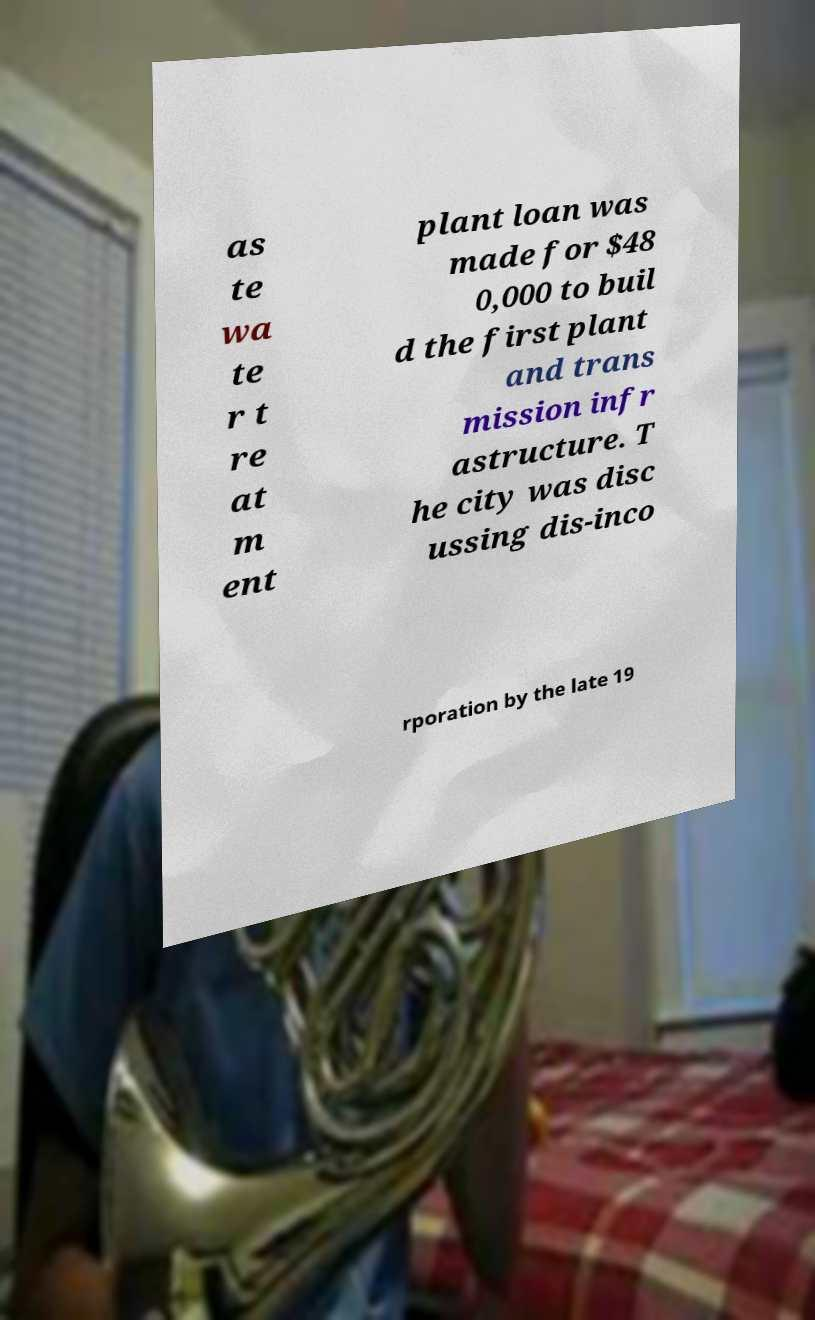What messages or text are displayed in this image? I need them in a readable, typed format. as te wa te r t re at m ent plant loan was made for $48 0,000 to buil d the first plant and trans mission infr astructure. T he city was disc ussing dis-inco rporation by the late 19 